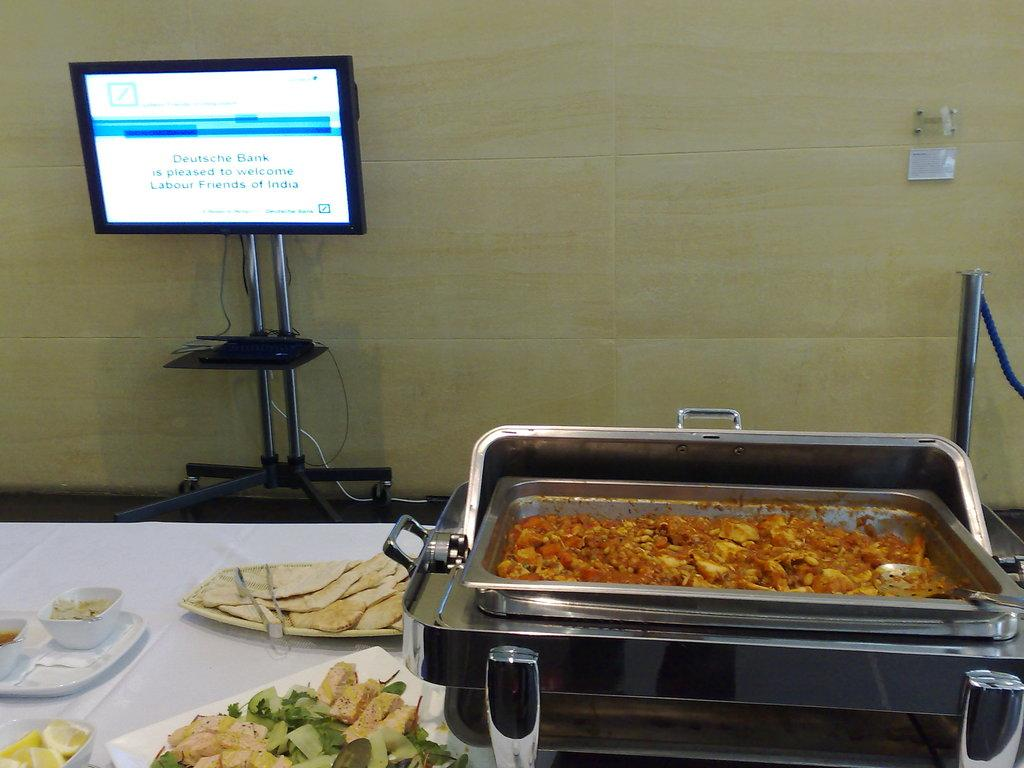<image>
Present a compact description of the photo's key features. Just beyond a table of food a monitor shows that this event was sponsored by Deutsche Bank. 